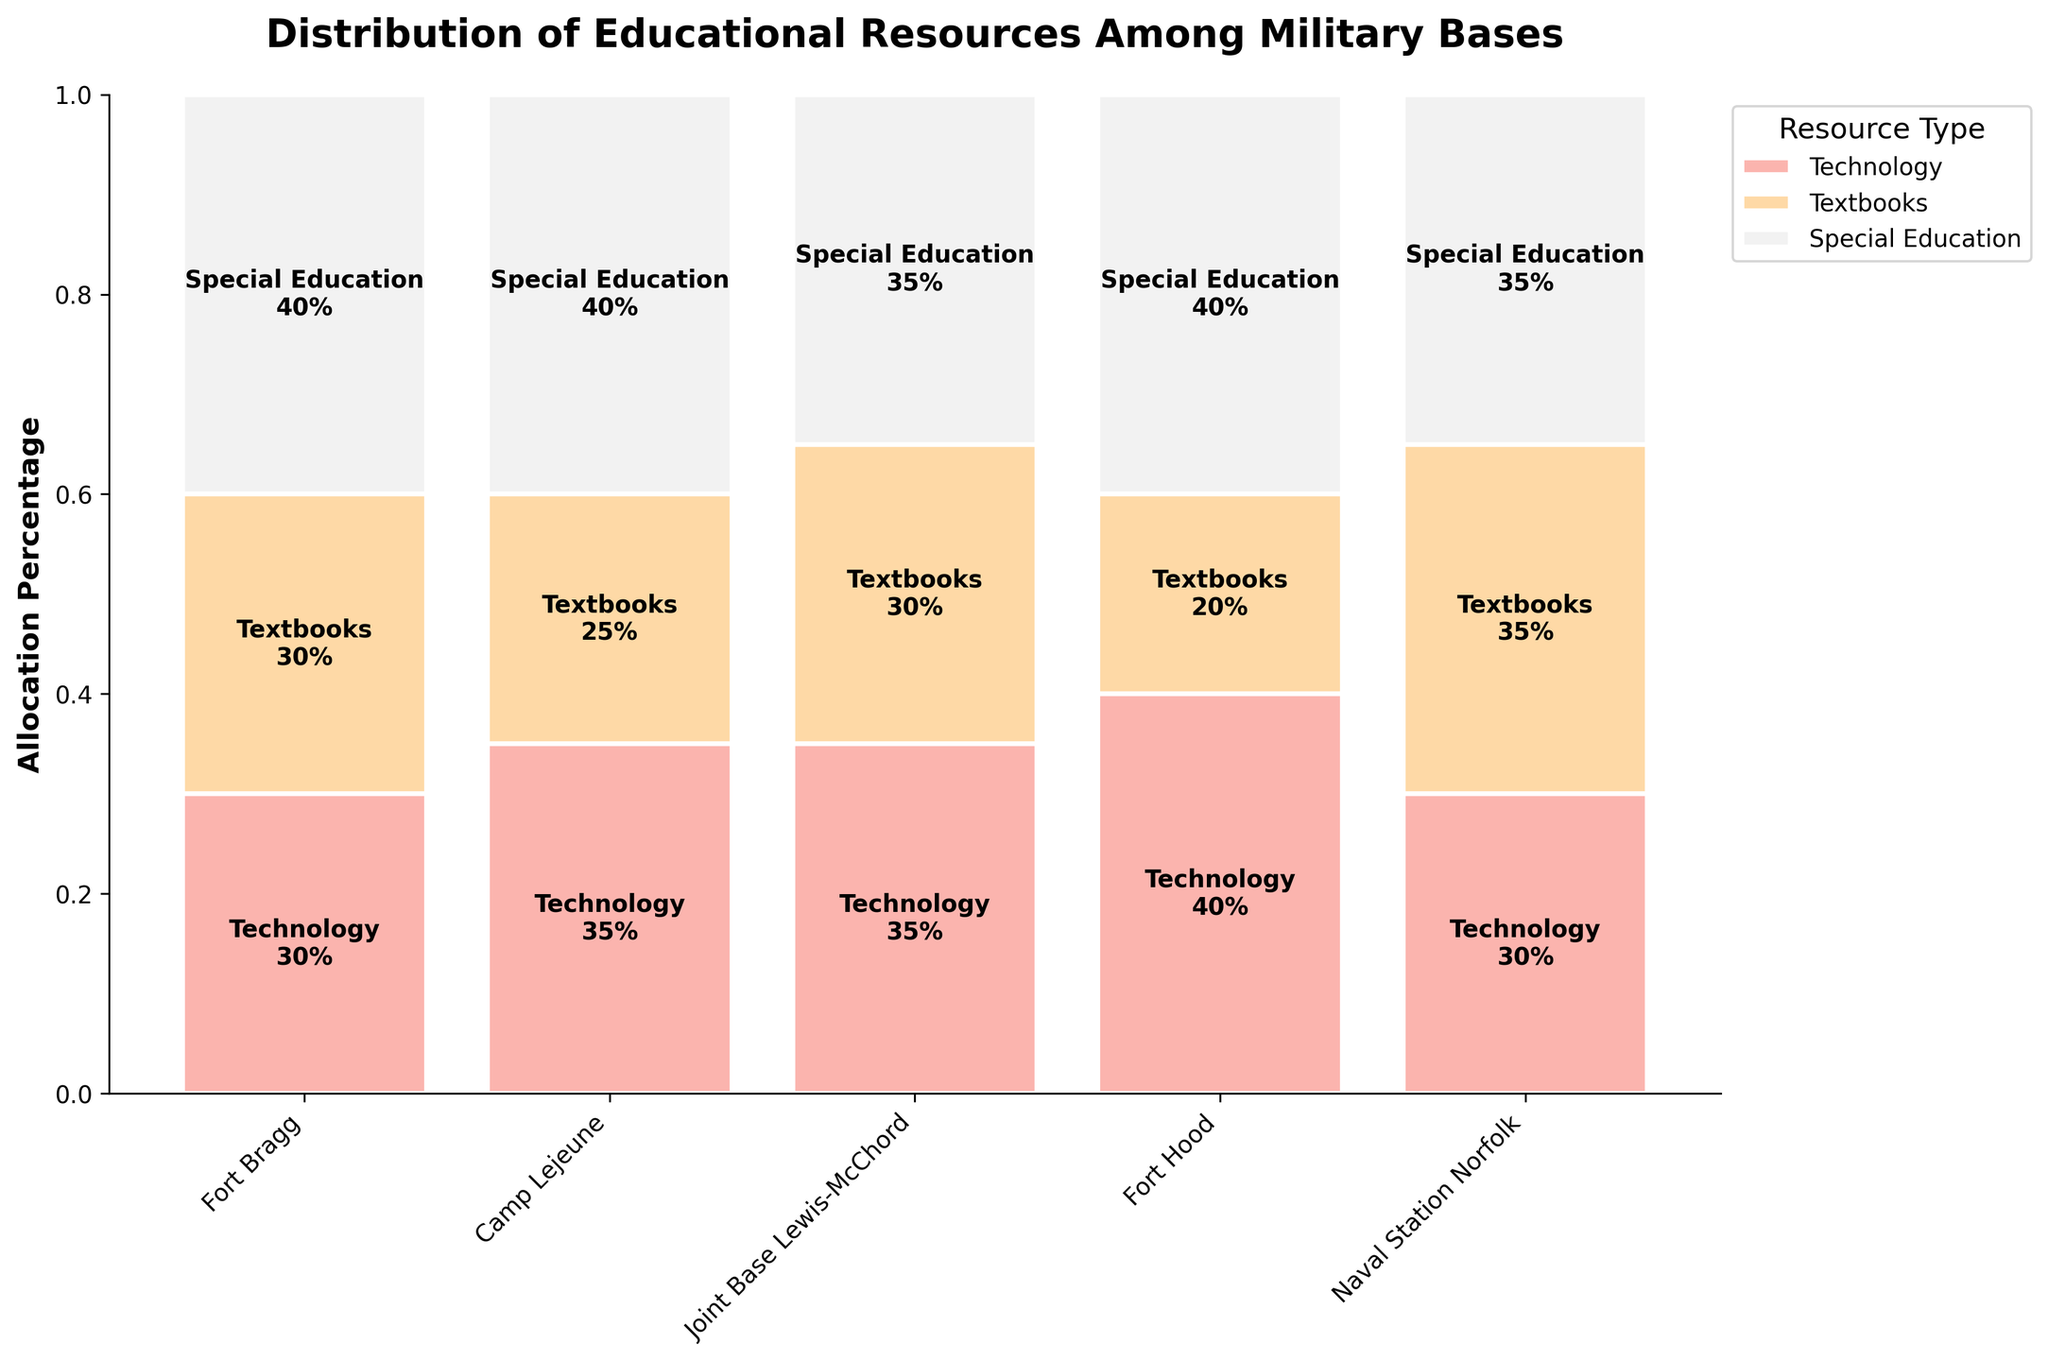What is the title of the figure? The title of the figure is usually displayed at the top of the chart. It is meant to provide an overview of what the figure is about. In this case, the title reads, "Distribution of Educational Resources Among Military Bases."
Answer: Distribution of Educational Resources Among Military Bases Which military base has the highest allocation percentage for technology resources? The bars for technology resources are color-coded and labeled. By looking at the heights of the technology bars for each military base, one can identify that Joint Base Lewis-McChord has the highest allocation percentage for technology at 40%.
Answer: Joint Base Lewis-McChord What is the total allocation percentage for resources in Naval Station Norfolk? To find the total allocation percentage for Naval Station Norfolk, we add the allocation percentages for technology, textbooks, and special education. These are shown as the stack of bars for each resource type. The values are 30% (technology) + 35% (textbooks) + 35% (special education) = 100%.
Answer: 100% Compare the allocation percentage for textbooks between Fort Bragg and Camp Lejeune. Which one is higher? The heights of the textbook bars are compared for both Fort Bragg and Camp Lejeune. Fort Bragg has an allocation percentage of 25% for textbooks, while Camp Lejeune has 30%. Therefore, Camp Lejeune has a higher allocation percentage for textbooks.
Answer: Camp Lejeune What is the combined allocation percentage for special education across all military bases? To find the combined allocation percentage, sum the percentages for special education across all bases. These are 40% (Fort Bragg) + 40% (Camp Lejeune) + 40% (Joint Base Lewis-McChord) + 35% (Fort Hood) + 35% (Naval Station Norfolk). This equals to 40% + 40% + 40% + 35% + 35% = 190%.
Answer: 190% Which resource type has the most uniform allocation across all military bases? By examining the heights of the bars for each resource type across all bases, it becomes evident that special education has the most uniform allocation, with values close to 40% for most bases.
Answer: Special Education Are there any bases where the allocation for textbooks exceeds the allocation for technology? By comparing the heights of the textbook and technology bars for each base, it can be seen that Naval Station Norfolk is the only base where the allocation for textbooks (35%) exceeds the allocation for technology (30%).
Answer: Naval Station Norfolk What is the range of allocation percentage for technology among the military bases? The range is found by identifying the highest and lowest percentages for technology allocation. The highest is 40% (Joint Base Lewis-McChord), and the lowest is 30% (Camp Lejeune and Naval Station Norfolk). The range is 40% - 30% = 10%.
Answer: 10% 